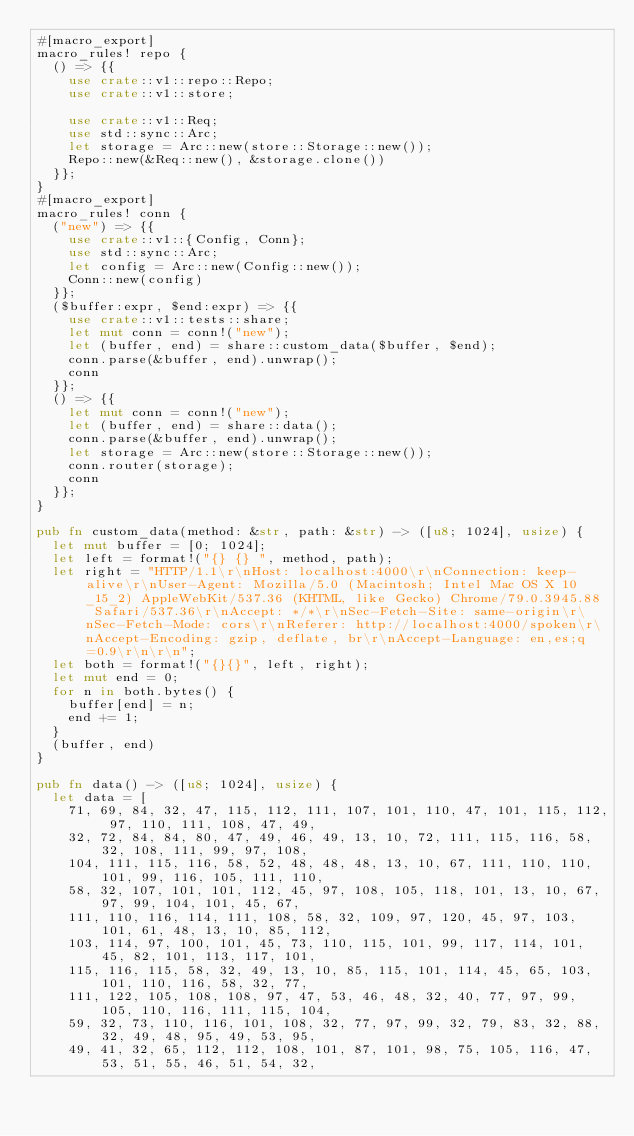Convert code to text. <code><loc_0><loc_0><loc_500><loc_500><_Rust_>#[macro_export]
macro_rules! repo {
  () => {{
    use crate::v1::repo::Repo;
    use crate::v1::store;

    use crate::v1::Req;
    use std::sync::Arc;
    let storage = Arc::new(store::Storage::new());
    Repo::new(&Req::new(), &storage.clone())
  }};
}
#[macro_export]
macro_rules! conn {
  ("new") => {{
    use crate::v1::{Config, Conn};
    use std::sync::Arc;
    let config = Arc::new(Config::new());
    Conn::new(config)
  }};
  ($buffer:expr, $end:expr) => {{
    use crate::v1::tests::share;
    let mut conn = conn!("new");
    let (buffer, end) = share::custom_data($buffer, $end);
    conn.parse(&buffer, end).unwrap();
    conn
  }};
  () => {{
    let mut conn = conn!("new");
    let (buffer, end) = share::data();
    conn.parse(&buffer, end).unwrap();
    let storage = Arc::new(store::Storage::new());
    conn.router(storage);
    conn
  }};
}

pub fn custom_data(method: &str, path: &str) -> ([u8; 1024], usize) {
  let mut buffer = [0; 1024];
  let left = format!("{} {} ", method, path);
  let right = "HTTP/1.1\r\nHost: localhost:4000\r\nConnection: keep-alive\r\nUser-Agent: Mozilla/5.0 (Macintosh; Intel Mac OS X 10_15_2) AppleWebKit/537.36 (KHTML, like Gecko) Chrome/79.0.3945.88 Safari/537.36\r\nAccept: */*\r\nSec-Fetch-Site: same-origin\r\nSec-Fetch-Mode: cors\r\nReferer: http://localhost:4000/spoken\r\nAccept-Encoding: gzip, deflate, br\r\nAccept-Language: en,es;q=0.9\r\n\r\n";
  let both = format!("{}{}", left, right);
  let mut end = 0;
  for n in both.bytes() {
    buffer[end] = n;
    end += 1;
  }
  (buffer, end)
}

pub fn data() -> ([u8; 1024], usize) {
  let data = [
    71, 69, 84, 32, 47, 115, 112, 111, 107, 101, 110, 47, 101, 115, 112, 97, 110, 111, 108, 47, 49,
    32, 72, 84, 84, 80, 47, 49, 46, 49, 13, 10, 72, 111, 115, 116, 58, 32, 108, 111, 99, 97, 108,
    104, 111, 115, 116, 58, 52, 48, 48, 48, 13, 10, 67, 111, 110, 110, 101, 99, 116, 105, 111, 110,
    58, 32, 107, 101, 101, 112, 45, 97, 108, 105, 118, 101, 13, 10, 67, 97, 99, 104, 101, 45, 67,
    111, 110, 116, 114, 111, 108, 58, 32, 109, 97, 120, 45, 97, 103, 101, 61, 48, 13, 10, 85, 112,
    103, 114, 97, 100, 101, 45, 73, 110, 115, 101, 99, 117, 114, 101, 45, 82, 101, 113, 117, 101,
    115, 116, 115, 58, 32, 49, 13, 10, 85, 115, 101, 114, 45, 65, 103, 101, 110, 116, 58, 32, 77,
    111, 122, 105, 108, 108, 97, 47, 53, 46, 48, 32, 40, 77, 97, 99, 105, 110, 116, 111, 115, 104,
    59, 32, 73, 110, 116, 101, 108, 32, 77, 97, 99, 32, 79, 83, 32, 88, 32, 49, 48, 95, 49, 53, 95,
    49, 41, 32, 65, 112, 112, 108, 101, 87, 101, 98, 75, 105, 116, 47, 53, 51, 55, 46, 51, 54, 32,</code> 